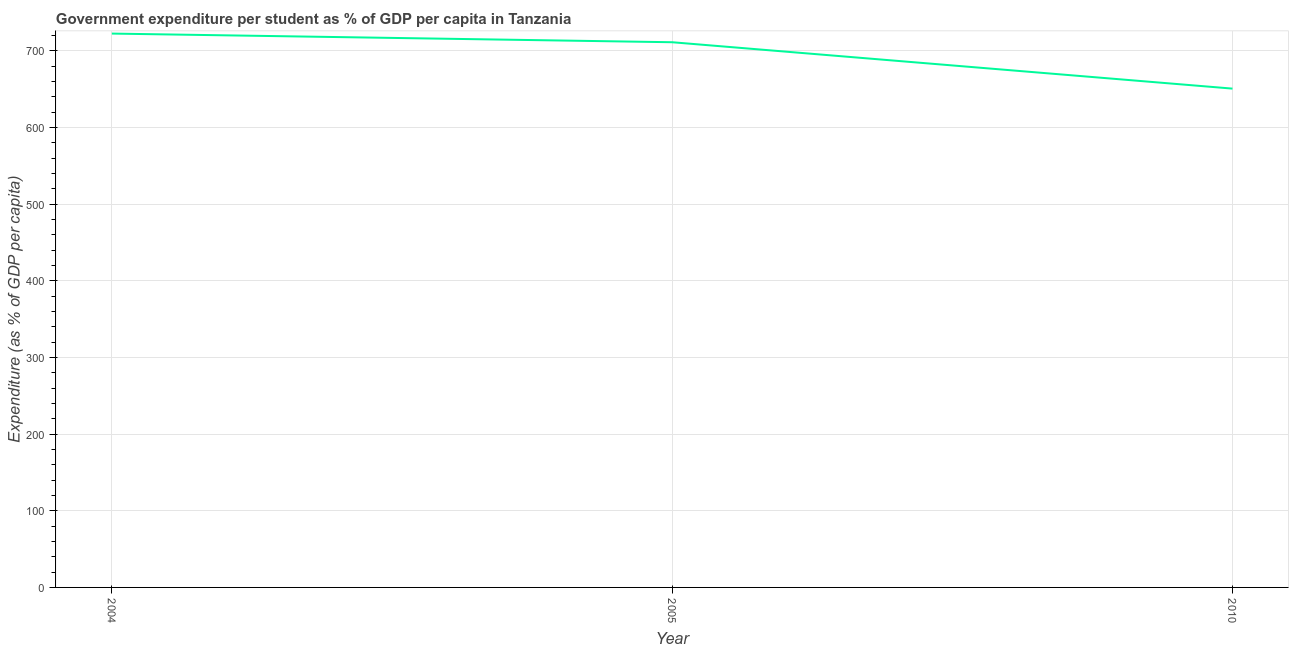What is the government expenditure per student in 2010?
Offer a very short reply. 650.78. Across all years, what is the maximum government expenditure per student?
Give a very brief answer. 722.6. Across all years, what is the minimum government expenditure per student?
Your answer should be very brief. 650.78. What is the sum of the government expenditure per student?
Make the answer very short. 2084.68. What is the difference between the government expenditure per student in 2005 and 2010?
Your response must be concise. 60.52. What is the average government expenditure per student per year?
Keep it short and to the point. 694.89. What is the median government expenditure per student?
Your response must be concise. 711.3. In how many years, is the government expenditure per student greater than 300 %?
Your response must be concise. 3. What is the ratio of the government expenditure per student in 2004 to that in 2010?
Keep it short and to the point. 1.11. Is the government expenditure per student in 2004 less than that in 2005?
Your answer should be compact. No. Is the difference between the government expenditure per student in 2005 and 2010 greater than the difference between any two years?
Give a very brief answer. No. What is the difference between the highest and the second highest government expenditure per student?
Ensure brevity in your answer.  11.29. Is the sum of the government expenditure per student in 2004 and 2010 greater than the maximum government expenditure per student across all years?
Keep it short and to the point. Yes. What is the difference between the highest and the lowest government expenditure per student?
Provide a succinct answer. 71.81. How many lines are there?
Give a very brief answer. 1. What is the difference between two consecutive major ticks on the Y-axis?
Make the answer very short. 100. Are the values on the major ticks of Y-axis written in scientific E-notation?
Provide a succinct answer. No. What is the title of the graph?
Your answer should be very brief. Government expenditure per student as % of GDP per capita in Tanzania. What is the label or title of the Y-axis?
Give a very brief answer. Expenditure (as % of GDP per capita). What is the Expenditure (as % of GDP per capita) in 2004?
Provide a short and direct response. 722.6. What is the Expenditure (as % of GDP per capita) in 2005?
Offer a terse response. 711.3. What is the Expenditure (as % of GDP per capita) in 2010?
Give a very brief answer. 650.78. What is the difference between the Expenditure (as % of GDP per capita) in 2004 and 2005?
Provide a short and direct response. 11.29. What is the difference between the Expenditure (as % of GDP per capita) in 2004 and 2010?
Provide a succinct answer. 71.81. What is the difference between the Expenditure (as % of GDP per capita) in 2005 and 2010?
Your answer should be very brief. 60.52. What is the ratio of the Expenditure (as % of GDP per capita) in 2004 to that in 2010?
Keep it short and to the point. 1.11. What is the ratio of the Expenditure (as % of GDP per capita) in 2005 to that in 2010?
Provide a succinct answer. 1.09. 